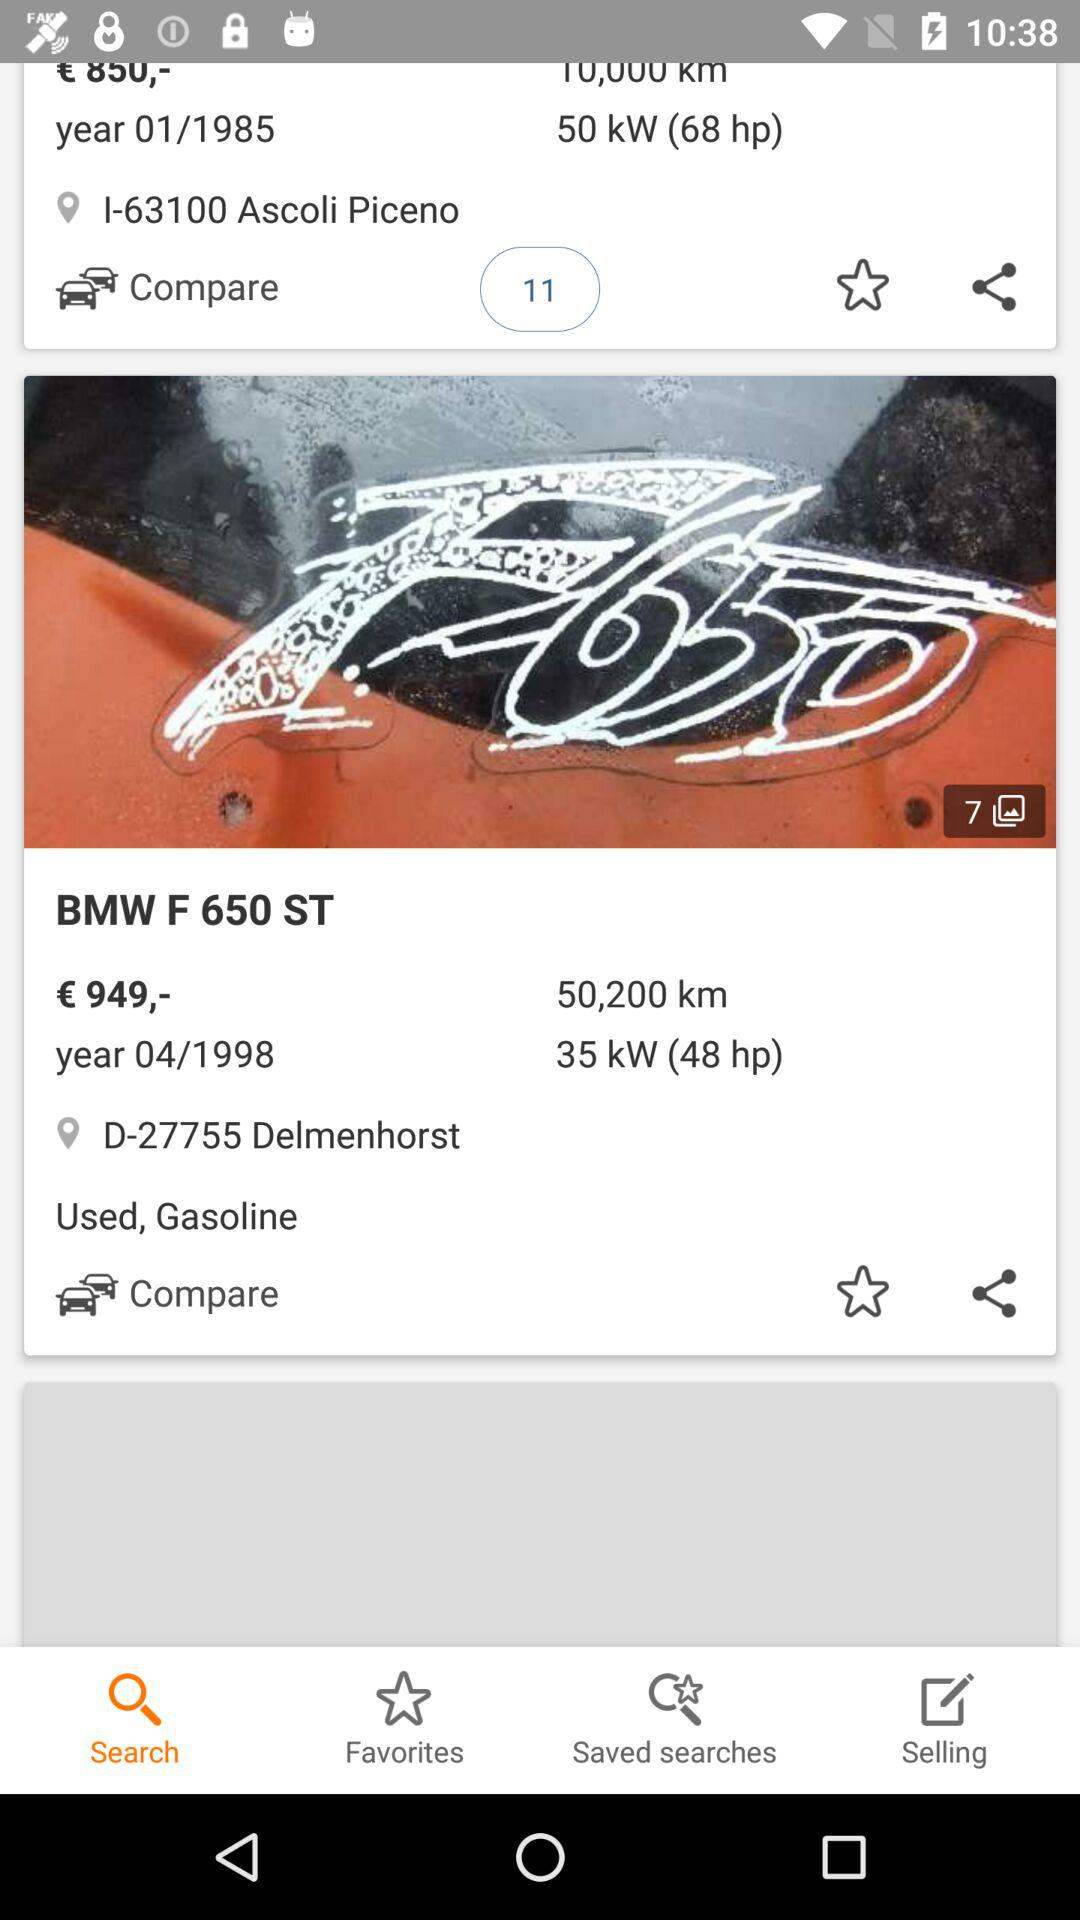What is the price of the vehicle? The price of the vehicle is €949. 